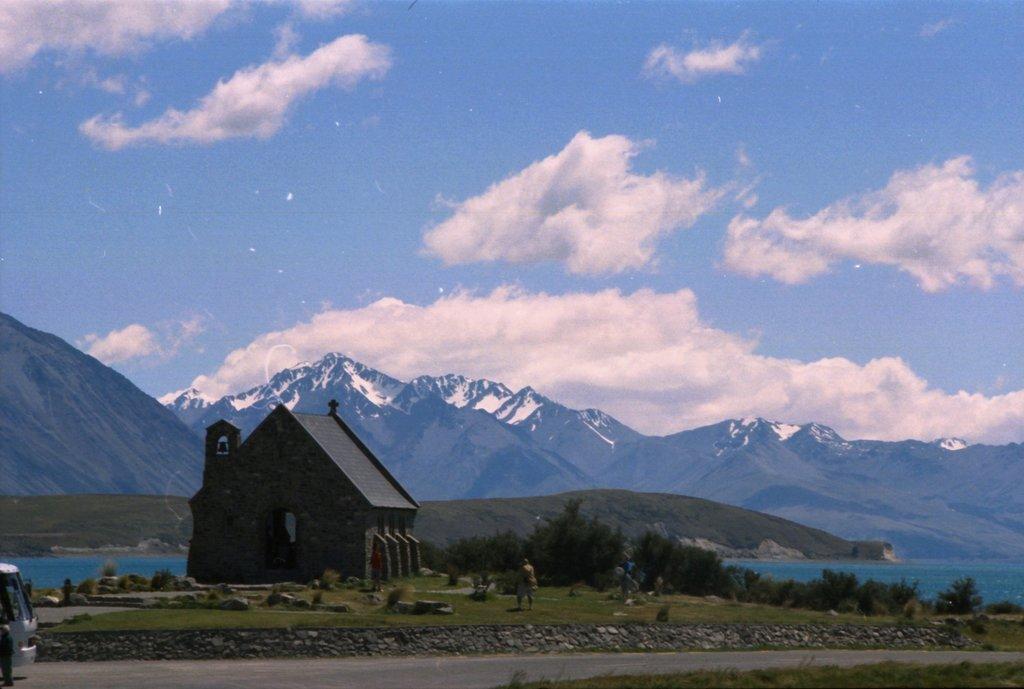How would you summarize this image in a sentence or two? In this image we can see a house and a person, there are some stones, plants, water, grass, mountains and a vehicle, in the background we can see the sky with clouds. 